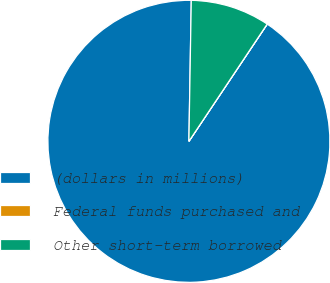Convert chart to OTSL. <chart><loc_0><loc_0><loc_500><loc_500><pie_chart><fcel>(dollars in millions)<fcel>Federal funds purchased and<fcel>Other short-term borrowed<nl><fcel>90.9%<fcel>0.01%<fcel>9.1%<nl></chart> 